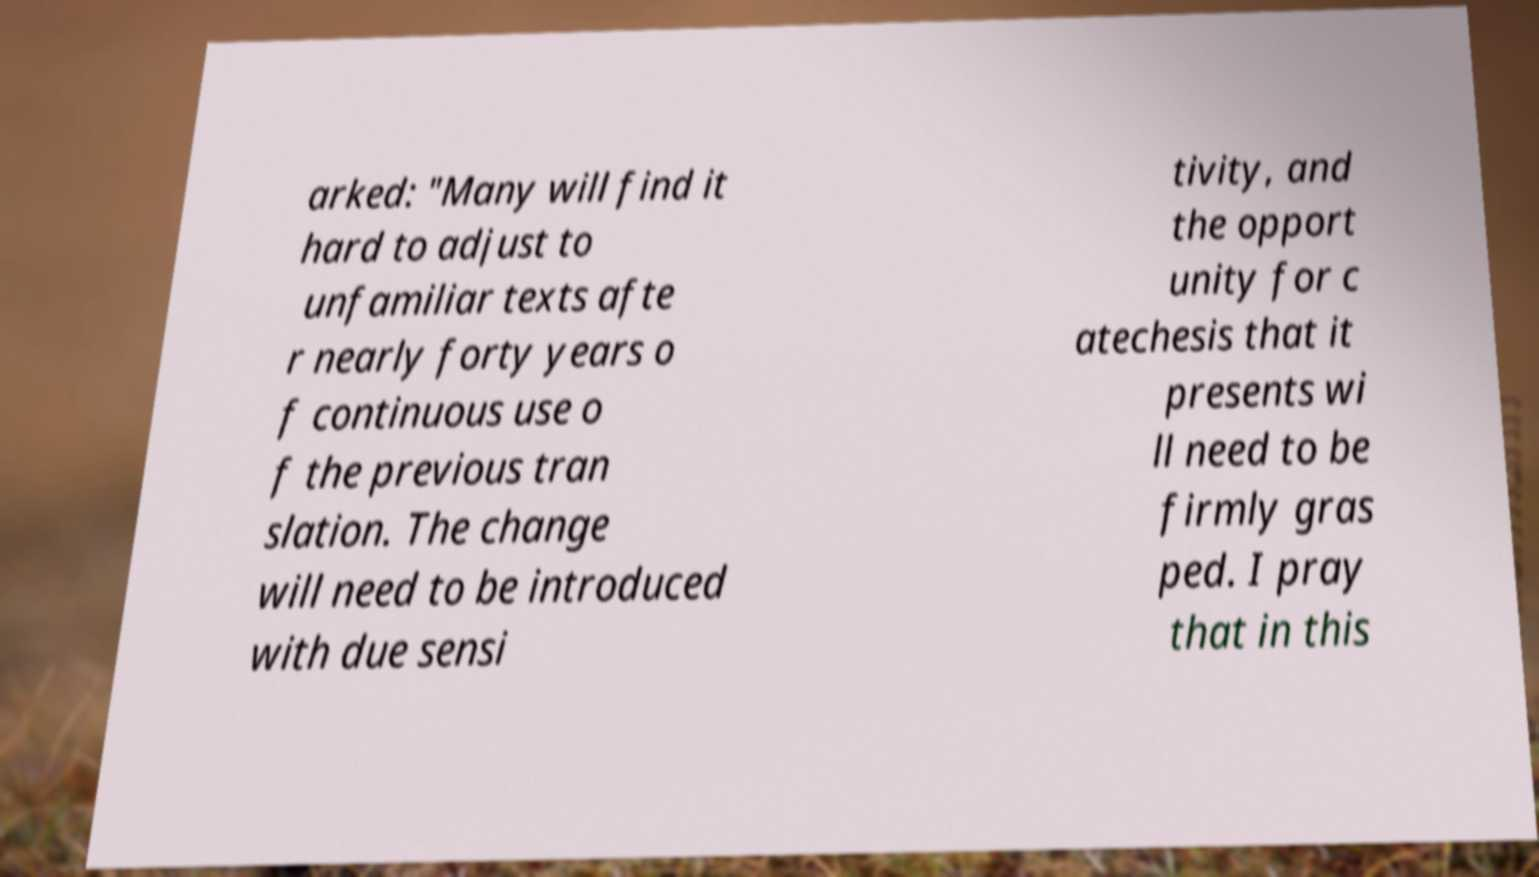There's text embedded in this image that I need extracted. Can you transcribe it verbatim? arked: "Many will find it hard to adjust to unfamiliar texts afte r nearly forty years o f continuous use o f the previous tran slation. The change will need to be introduced with due sensi tivity, and the opport unity for c atechesis that it presents wi ll need to be firmly gras ped. I pray that in this 